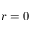Convert formula to latex. <formula><loc_0><loc_0><loc_500><loc_500>r = 0</formula> 